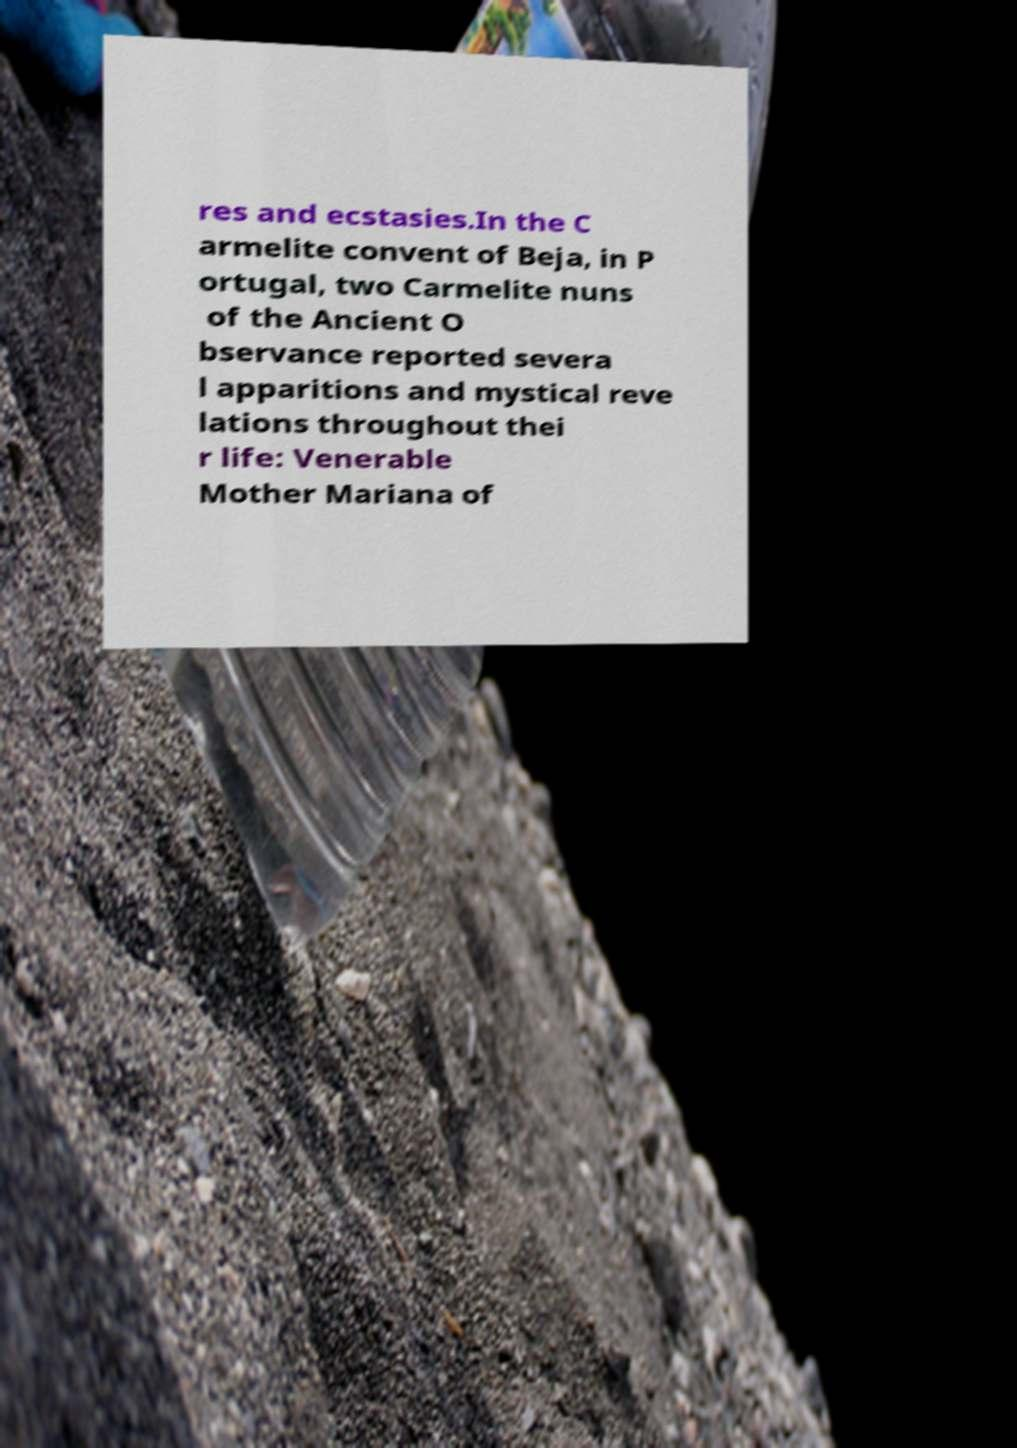I need the written content from this picture converted into text. Can you do that? res and ecstasies.In the C armelite convent of Beja, in P ortugal, two Carmelite nuns of the Ancient O bservance reported severa l apparitions and mystical reve lations throughout thei r life: Venerable Mother Mariana of 